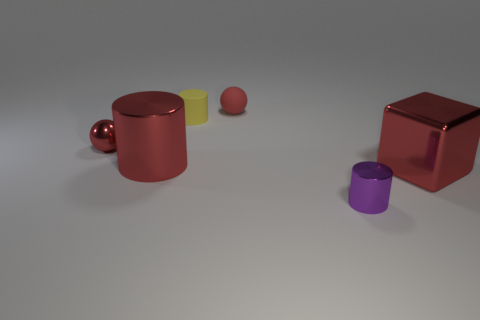Add 1 yellow rubber objects. How many objects exist? 7 Subtract all cubes. How many objects are left? 5 Subtract 0 gray cubes. How many objects are left? 6 Subtract all big metal things. Subtract all tiny gray matte balls. How many objects are left? 4 Add 5 red shiny spheres. How many red shiny spheres are left? 6 Add 6 large brown metal balls. How many large brown metal balls exist? 6 